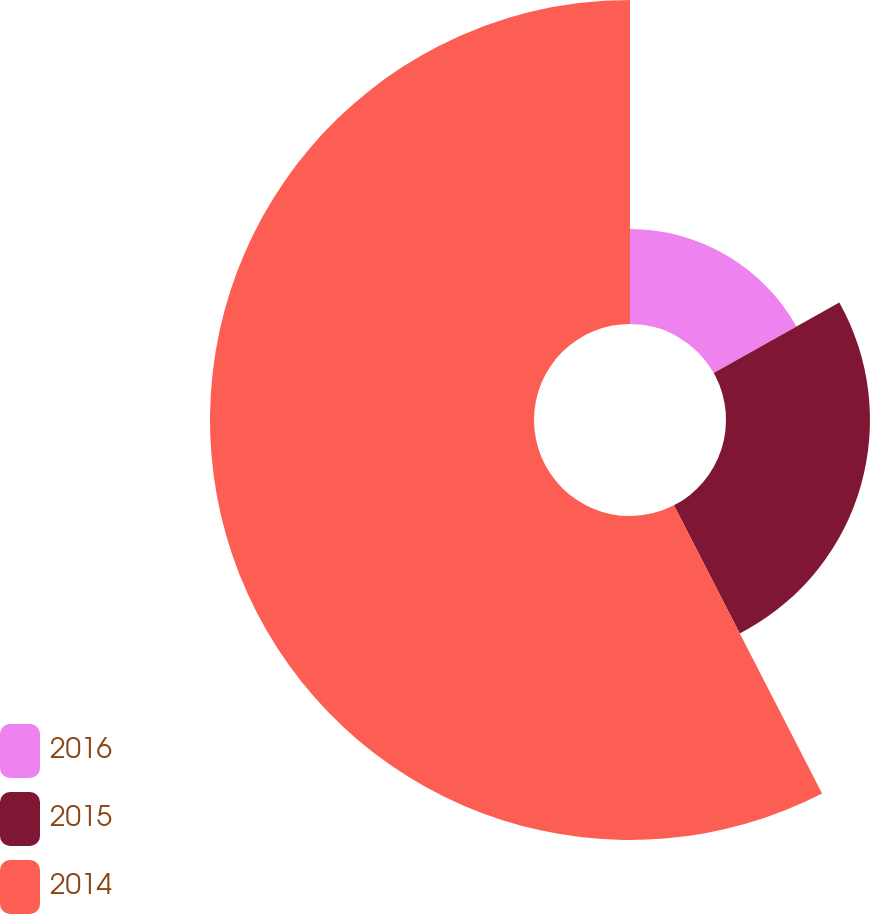Convert chart to OTSL. <chart><loc_0><loc_0><loc_500><loc_500><pie_chart><fcel>2016<fcel>2015<fcel>2014<nl><fcel>16.86%<fcel>25.58%<fcel>57.56%<nl></chart> 